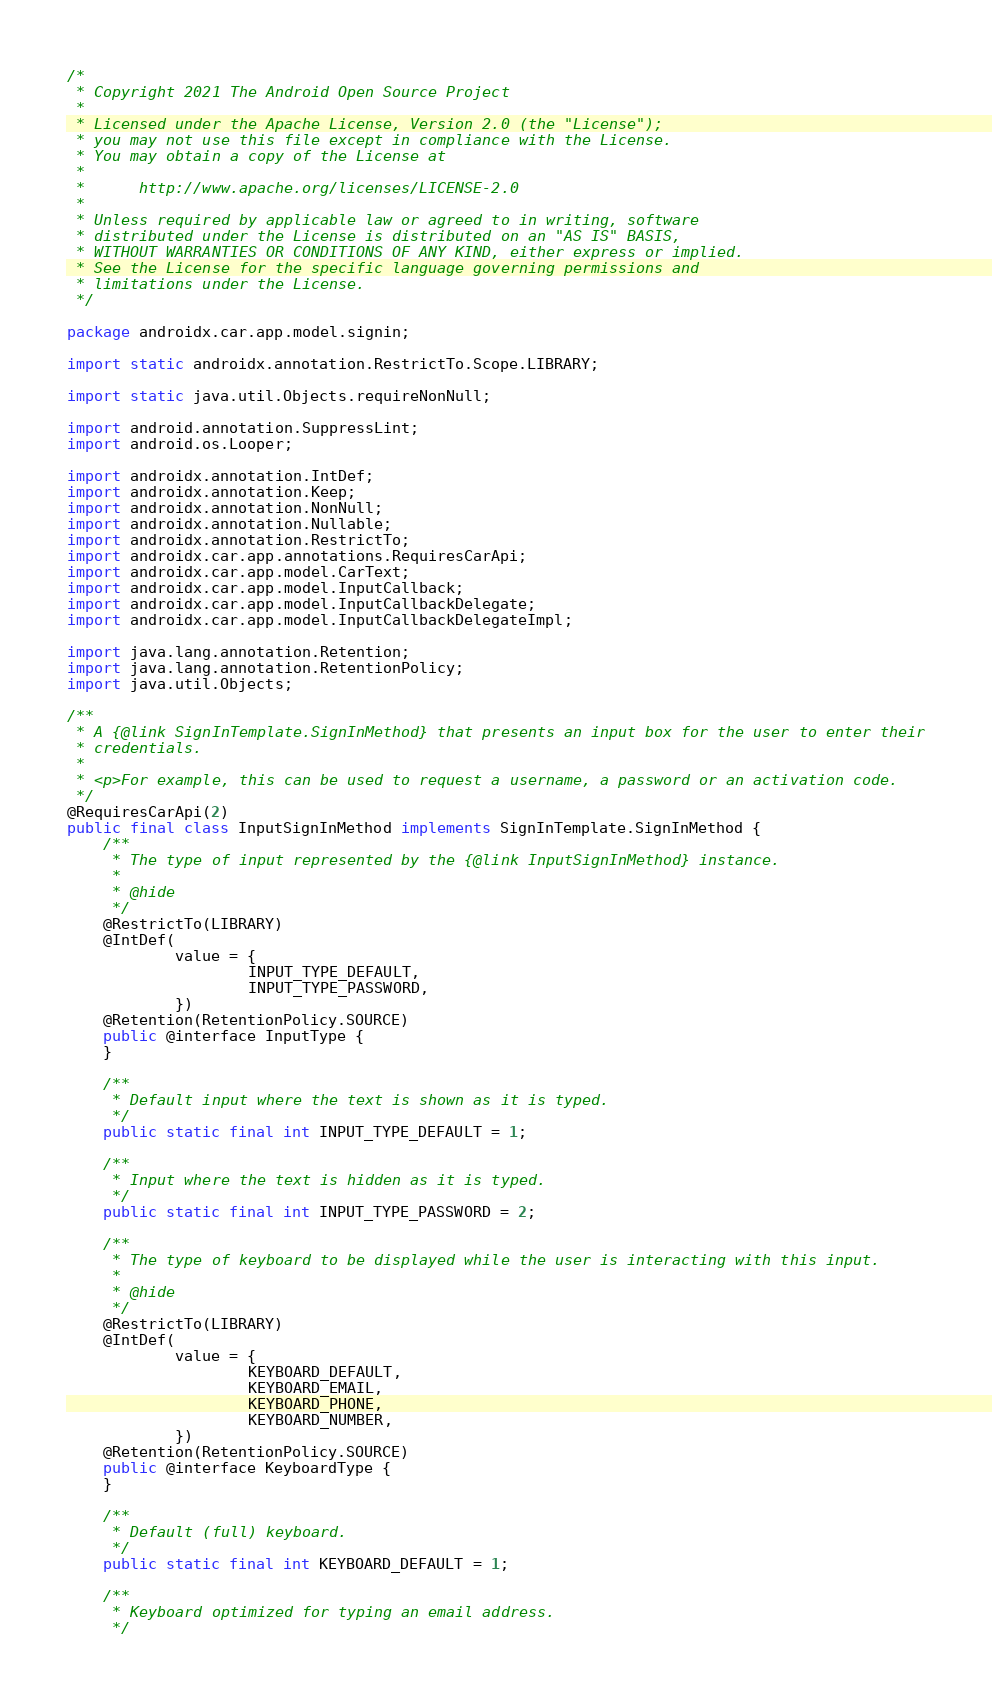Convert code to text. <code><loc_0><loc_0><loc_500><loc_500><_Java_>/*
 * Copyright 2021 The Android Open Source Project
 *
 * Licensed under the Apache License, Version 2.0 (the "License");
 * you may not use this file except in compliance with the License.
 * You may obtain a copy of the License at
 *
 *      http://www.apache.org/licenses/LICENSE-2.0
 *
 * Unless required by applicable law or agreed to in writing, software
 * distributed under the License is distributed on an "AS IS" BASIS,
 * WITHOUT WARRANTIES OR CONDITIONS OF ANY KIND, either express or implied.
 * See the License for the specific language governing permissions and
 * limitations under the License.
 */

package androidx.car.app.model.signin;

import static androidx.annotation.RestrictTo.Scope.LIBRARY;

import static java.util.Objects.requireNonNull;

import android.annotation.SuppressLint;
import android.os.Looper;

import androidx.annotation.IntDef;
import androidx.annotation.Keep;
import androidx.annotation.NonNull;
import androidx.annotation.Nullable;
import androidx.annotation.RestrictTo;
import androidx.car.app.annotations.RequiresCarApi;
import androidx.car.app.model.CarText;
import androidx.car.app.model.InputCallback;
import androidx.car.app.model.InputCallbackDelegate;
import androidx.car.app.model.InputCallbackDelegateImpl;

import java.lang.annotation.Retention;
import java.lang.annotation.RetentionPolicy;
import java.util.Objects;

/**
 * A {@link SignInTemplate.SignInMethod} that presents an input box for the user to enter their
 * credentials.
 *
 * <p>For example, this can be used to request a username, a password or an activation code.
 */
@RequiresCarApi(2)
public final class InputSignInMethod implements SignInTemplate.SignInMethod {
    /**
     * The type of input represented by the {@link InputSignInMethod} instance.
     *
     * @hide
     */
    @RestrictTo(LIBRARY)
    @IntDef(
            value = {
                    INPUT_TYPE_DEFAULT,
                    INPUT_TYPE_PASSWORD,
            })
    @Retention(RetentionPolicy.SOURCE)
    public @interface InputType {
    }

    /**
     * Default input where the text is shown as it is typed.
     */
    public static final int INPUT_TYPE_DEFAULT = 1;

    /**
     * Input where the text is hidden as it is typed.
     */
    public static final int INPUT_TYPE_PASSWORD = 2;

    /**
     * The type of keyboard to be displayed while the user is interacting with this input.
     *
     * @hide
     */
    @RestrictTo(LIBRARY)
    @IntDef(
            value = {
                    KEYBOARD_DEFAULT,
                    KEYBOARD_EMAIL,
                    KEYBOARD_PHONE,
                    KEYBOARD_NUMBER,
            })
    @Retention(RetentionPolicy.SOURCE)
    public @interface KeyboardType {
    }

    /**
     * Default (full) keyboard.
     */
    public static final int KEYBOARD_DEFAULT = 1;

    /**
     * Keyboard optimized for typing an email address.
     */</code> 